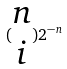Convert formula to latex. <formula><loc_0><loc_0><loc_500><loc_500>( \begin{matrix} n \\ i \end{matrix} ) 2 ^ { - n }</formula> 